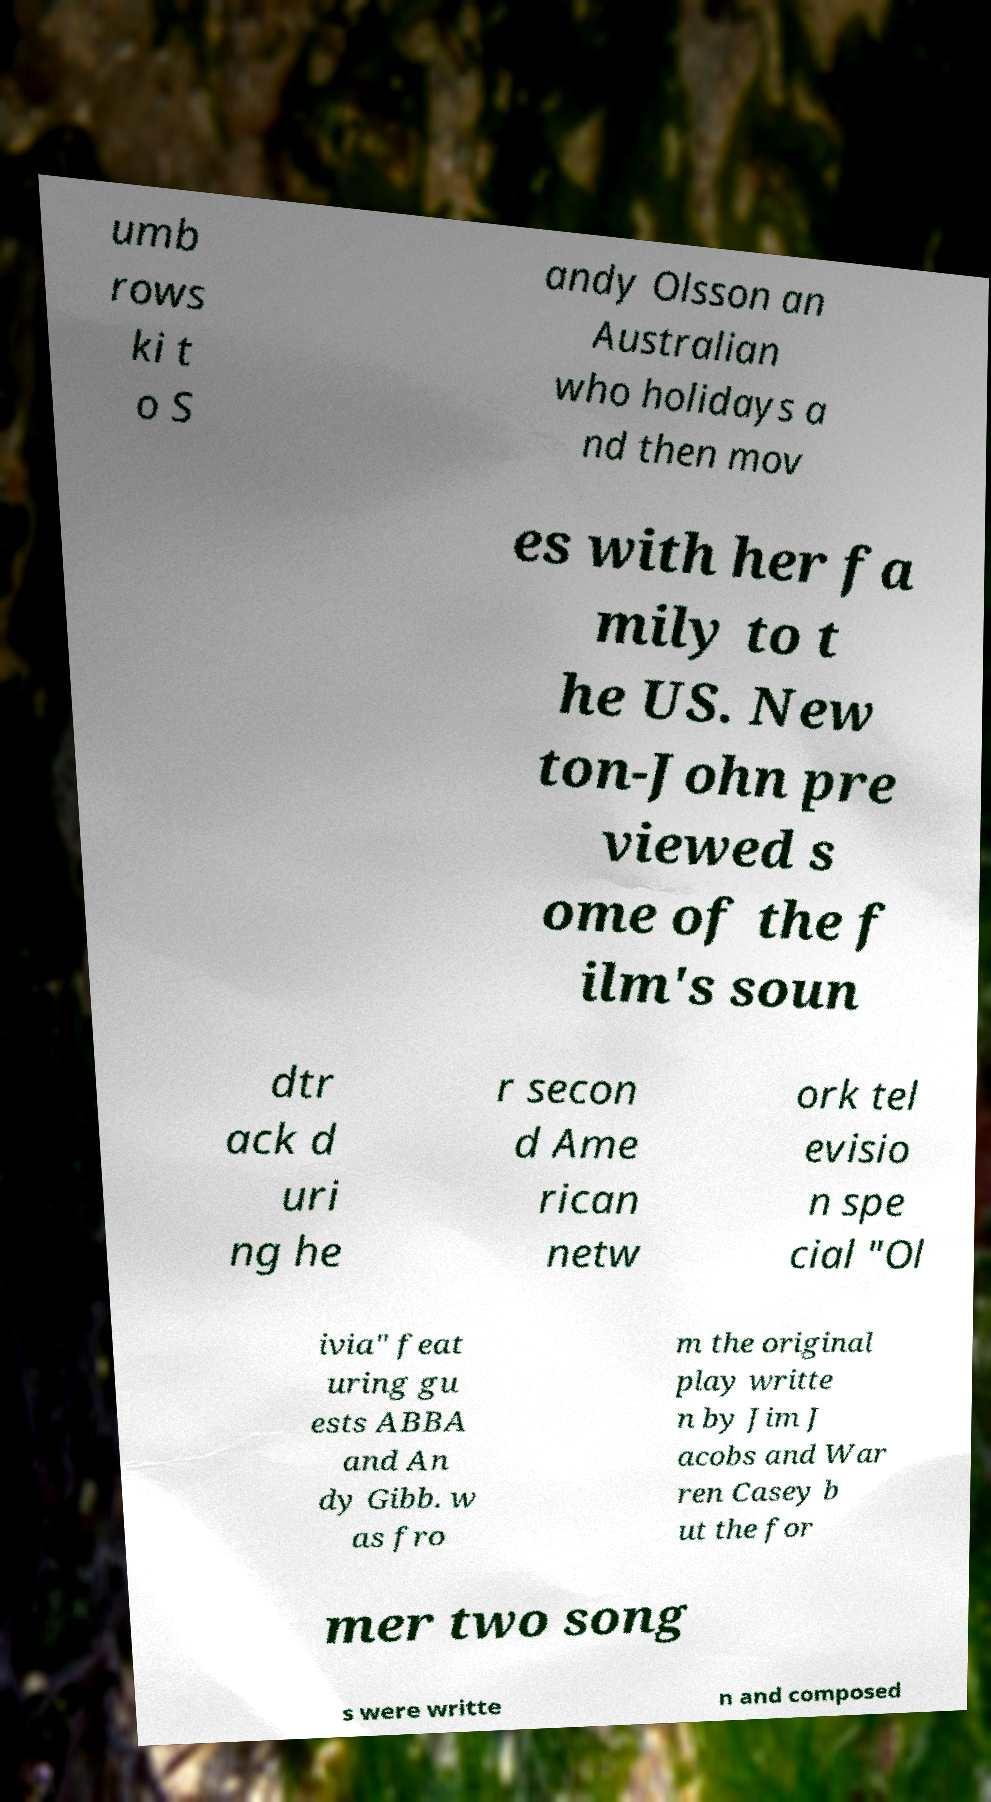Can you read and provide the text displayed in the image?This photo seems to have some interesting text. Can you extract and type it out for me? umb rows ki t o S andy Olsson an Australian who holidays a nd then mov es with her fa mily to t he US. New ton-John pre viewed s ome of the f ilm's soun dtr ack d uri ng he r secon d Ame rican netw ork tel evisio n spe cial "Ol ivia" feat uring gu ests ABBA and An dy Gibb. w as fro m the original play writte n by Jim J acobs and War ren Casey b ut the for mer two song s were writte n and composed 